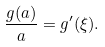Convert formula to latex. <formula><loc_0><loc_0><loc_500><loc_500>\frac { g ( a ) } { a } = g ^ { \prime } ( \xi ) .</formula> 